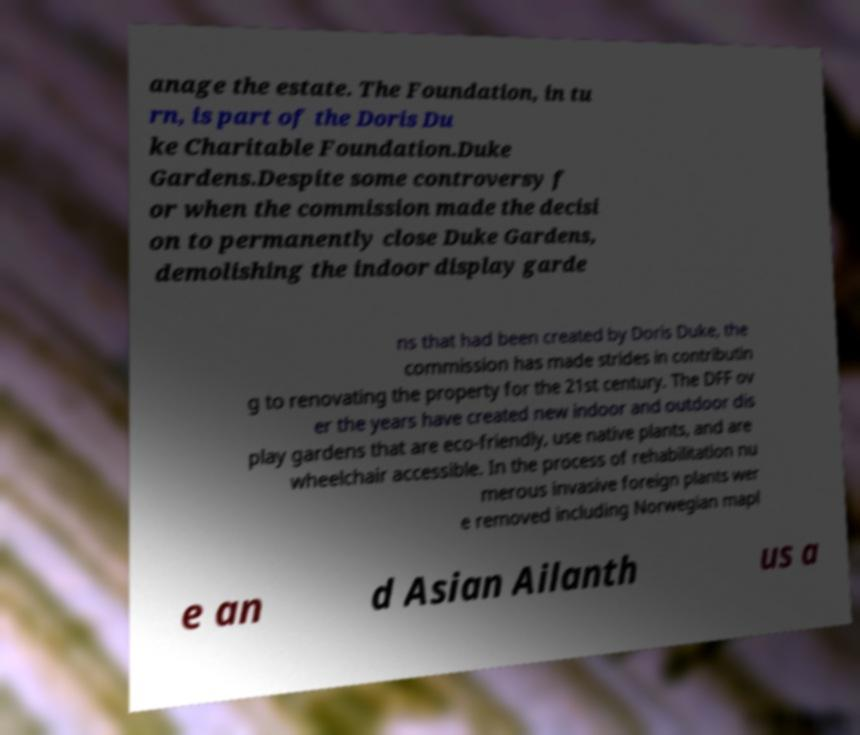Can you read and provide the text displayed in the image?This photo seems to have some interesting text. Can you extract and type it out for me? anage the estate. The Foundation, in tu rn, is part of the Doris Du ke Charitable Foundation.Duke Gardens.Despite some controversy f or when the commission made the decisi on to permanently close Duke Gardens, demolishing the indoor display garde ns that had been created by Doris Duke, the commission has made strides in contributin g to renovating the property for the 21st century. The DFF ov er the years have created new indoor and outdoor dis play gardens that are eco-friendly, use native plants, and are wheelchair accessible. In the process of rehabilitation nu merous invasive foreign plants wer e removed including Norwegian mapl e an d Asian Ailanth us a 